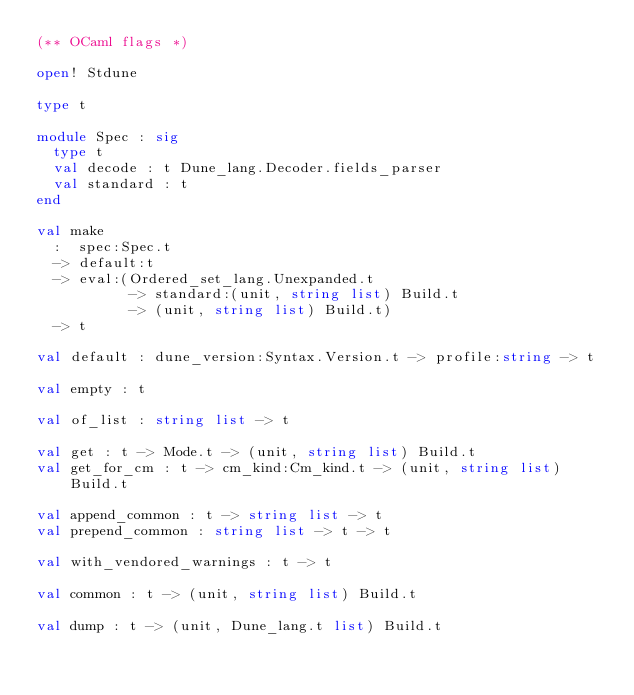<code> <loc_0><loc_0><loc_500><loc_500><_OCaml_>(** OCaml flags *)

open! Stdune

type t

module Spec : sig
  type t
  val decode : t Dune_lang.Decoder.fields_parser
  val standard : t
end

val make
  :  spec:Spec.t
  -> default:t
  -> eval:(Ordered_set_lang.Unexpanded.t
           -> standard:(unit, string list) Build.t
           -> (unit, string list) Build.t)
  -> t

val default : dune_version:Syntax.Version.t -> profile:string -> t

val empty : t

val of_list : string list -> t

val get : t -> Mode.t -> (unit, string list) Build.t
val get_for_cm : t -> cm_kind:Cm_kind.t -> (unit, string list) Build.t

val append_common : t -> string list -> t
val prepend_common : string list -> t -> t

val with_vendored_warnings : t -> t

val common : t -> (unit, string list) Build.t

val dump : t -> (unit, Dune_lang.t list) Build.t
</code> 